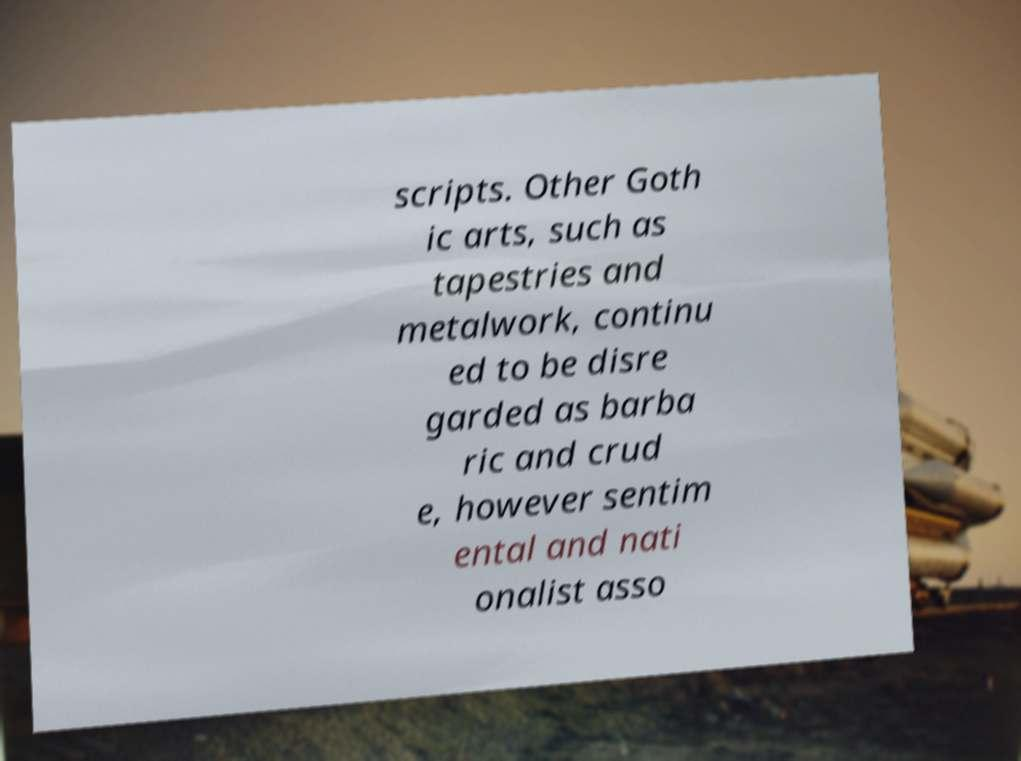Could you extract and type out the text from this image? scripts. Other Goth ic arts, such as tapestries and metalwork, continu ed to be disre garded as barba ric and crud e, however sentim ental and nati onalist asso 